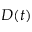Convert formula to latex. <formula><loc_0><loc_0><loc_500><loc_500>D ( t )</formula> 